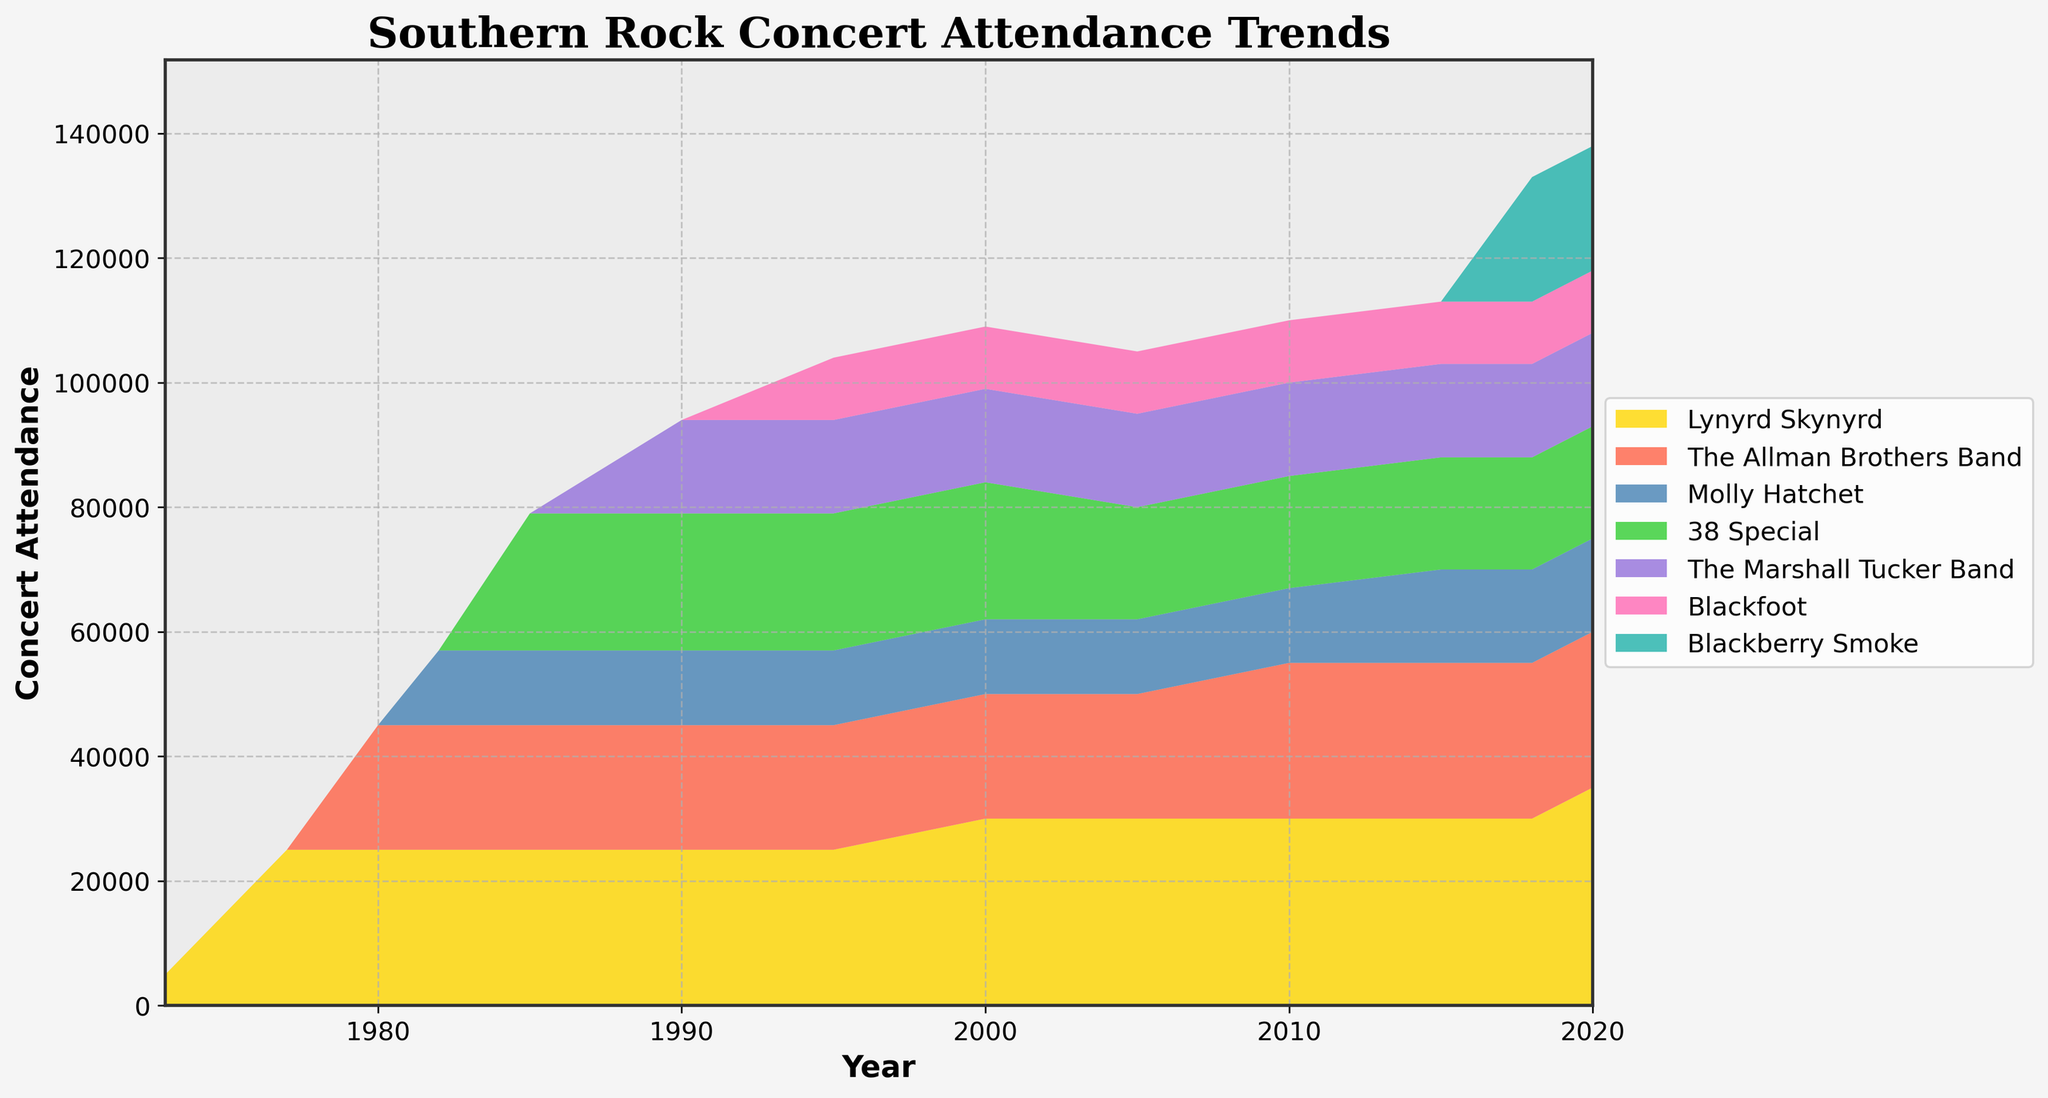What is the title of the chart? The title is located at the top of the figure and is often the largest text.
Answer: Southern Rock Concert Attendance Trends Which band had the highest concert attendance in 2020? Look at the rightmost end of the plot where the year is 2020 and identify the band with the tallest area for that year.
Answer: Lynyrd Skynyrd What trend can you observe for Lynyrd Skynyrd between 1973 and 2020? Identify Lynyrd Skynyrd's areas from the start to the end year and observe how they change over time.
Answer: Increasing trend How many bands are represented in this chart? Count the total distinct labels or areas that represent different bands in the legend or in the plot itself.
Answer: Seven bands Which year shows the highest total concert attendance for all bands combined? For each year, sum up the attendance values of all bands and compare them to find the year with the highest total.
Answer: 2020 Who had higher concert attendance in 2010, Lynyrd Skynyrd or The Allman Brothers Band? Locate the areas for Lynyrd Skynyrd and The Allman Brothers Band at the year 2010 and compare their heights.
Answer: The Allman Brothers Band Did any band show a consistent increase in concert attendance without any drop from one year to another? Examine each band's attendance over the years and see if the values steadily increase without falling.
Answer: No band Which band had a drop in concert attendance in 2005 compared to 1995? Look for bands that have a smaller area in 2005 compared to 1995 and identify them.
Answer: 38 Special Which band had the highest concert attendance in the year 1985? Locate the year 1985 on the x-axis, look at the corresponding sections, and identify the band with the tallest area for that year.
Answer: 38 Special How did The Allman Brothers Band's concert attendance change between 1980 and 2010? Check the area labeled for The Allman Brothers Band in the years 1980 and 2010 and compare their heights to see the change.
Answer: Increased 